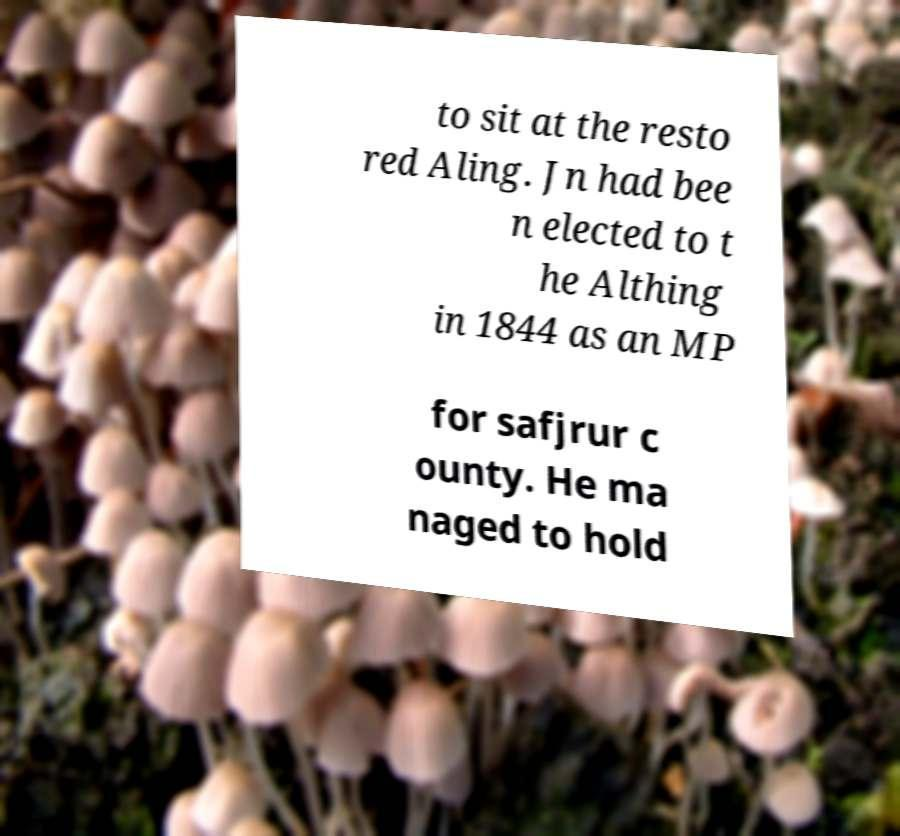What messages or text are displayed in this image? I need them in a readable, typed format. to sit at the resto red Aling. Jn had bee n elected to t he Althing in 1844 as an MP for safjrur c ounty. He ma naged to hold 